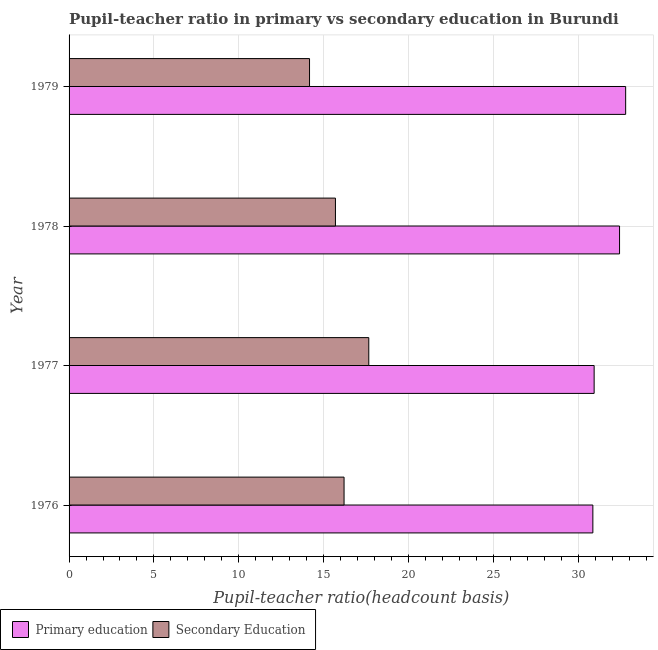How many different coloured bars are there?
Your answer should be very brief. 2. Are the number of bars on each tick of the Y-axis equal?
Your response must be concise. Yes. How many bars are there on the 4th tick from the top?
Provide a short and direct response. 2. How many bars are there on the 3rd tick from the bottom?
Offer a very short reply. 2. In how many cases, is the number of bars for a given year not equal to the number of legend labels?
Provide a succinct answer. 0. What is the pupil teacher ratio on secondary education in 1976?
Provide a succinct answer. 16.2. Across all years, what is the maximum pupil-teacher ratio in primary education?
Your response must be concise. 32.8. Across all years, what is the minimum pupil-teacher ratio in primary education?
Offer a terse response. 30.86. In which year was the pupil-teacher ratio in primary education minimum?
Your answer should be compact. 1976. What is the total pupil teacher ratio on secondary education in the graph?
Your response must be concise. 63.73. What is the difference between the pupil-teacher ratio in primary education in 1977 and that in 1979?
Keep it short and to the point. -1.86. What is the difference between the pupil teacher ratio on secondary education in 1979 and the pupil-teacher ratio in primary education in 1977?
Give a very brief answer. -16.77. What is the average pupil-teacher ratio in primary education per year?
Keep it short and to the point. 31.76. In the year 1978, what is the difference between the pupil teacher ratio on secondary education and pupil-teacher ratio in primary education?
Offer a very short reply. -16.74. What is the ratio of the pupil teacher ratio on secondary education in 1977 to that in 1978?
Offer a very short reply. 1.12. Is the difference between the pupil teacher ratio on secondary education in 1976 and 1979 greater than the difference between the pupil-teacher ratio in primary education in 1976 and 1979?
Give a very brief answer. Yes. What is the difference between the highest and the second highest pupil teacher ratio on secondary education?
Ensure brevity in your answer.  1.46. What is the difference between the highest and the lowest pupil teacher ratio on secondary education?
Your answer should be very brief. 3.49. What does the 2nd bar from the bottom in 1976 represents?
Provide a short and direct response. Secondary Education. How many years are there in the graph?
Your answer should be very brief. 4. What is the difference between two consecutive major ticks on the X-axis?
Your response must be concise. 5. Does the graph contain grids?
Offer a very short reply. Yes. Where does the legend appear in the graph?
Make the answer very short. Bottom left. How many legend labels are there?
Your answer should be compact. 2. How are the legend labels stacked?
Give a very brief answer. Horizontal. What is the title of the graph?
Give a very brief answer. Pupil-teacher ratio in primary vs secondary education in Burundi. Does "Net National savings" appear as one of the legend labels in the graph?
Your answer should be very brief. No. What is the label or title of the X-axis?
Offer a very short reply. Pupil-teacher ratio(headcount basis). What is the Pupil-teacher ratio(headcount basis) in Primary education in 1976?
Keep it short and to the point. 30.86. What is the Pupil-teacher ratio(headcount basis) in Secondary Education in 1976?
Provide a succinct answer. 16.2. What is the Pupil-teacher ratio(headcount basis) of Primary education in 1977?
Ensure brevity in your answer.  30.94. What is the Pupil-teacher ratio(headcount basis) of Secondary Education in 1977?
Provide a short and direct response. 17.66. What is the Pupil-teacher ratio(headcount basis) in Primary education in 1978?
Keep it short and to the point. 32.44. What is the Pupil-teacher ratio(headcount basis) in Secondary Education in 1978?
Keep it short and to the point. 15.7. What is the Pupil-teacher ratio(headcount basis) of Primary education in 1979?
Keep it short and to the point. 32.8. What is the Pupil-teacher ratio(headcount basis) in Secondary Education in 1979?
Your answer should be very brief. 14.17. Across all years, what is the maximum Pupil-teacher ratio(headcount basis) in Primary education?
Ensure brevity in your answer.  32.8. Across all years, what is the maximum Pupil-teacher ratio(headcount basis) in Secondary Education?
Your response must be concise. 17.66. Across all years, what is the minimum Pupil-teacher ratio(headcount basis) of Primary education?
Your answer should be compact. 30.86. Across all years, what is the minimum Pupil-teacher ratio(headcount basis) of Secondary Education?
Give a very brief answer. 14.17. What is the total Pupil-teacher ratio(headcount basis) in Primary education in the graph?
Your answer should be very brief. 127.04. What is the total Pupil-teacher ratio(headcount basis) of Secondary Education in the graph?
Make the answer very short. 63.73. What is the difference between the Pupil-teacher ratio(headcount basis) of Primary education in 1976 and that in 1977?
Offer a terse response. -0.08. What is the difference between the Pupil-teacher ratio(headcount basis) of Secondary Education in 1976 and that in 1977?
Offer a very short reply. -1.46. What is the difference between the Pupil-teacher ratio(headcount basis) in Primary education in 1976 and that in 1978?
Your response must be concise. -1.57. What is the difference between the Pupil-teacher ratio(headcount basis) of Secondary Education in 1976 and that in 1978?
Provide a short and direct response. 0.51. What is the difference between the Pupil-teacher ratio(headcount basis) of Primary education in 1976 and that in 1979?
Keep it short and to the point. -1.93. What is the difference between the Pupil-teacher ratio(headcount basis) in Secondary Education in 1976 and that in 1979?
Give a very brief answer. 2.03. What is the difference between the Pupil-teacher ratio(headcount basis) in Primary education in 1977 and that in 1978?
Give a very brief answer. -1.5. What is the difference between the Pupil-teacher ratio(headcount basis) of Secondary Education in 1977 and that in 1978?
Give a very brief answer. 1.97. What is the difference between the Pupil-teacher ratio(headcount basis) in Primary education in 1977 and that in 1979?
Your answer should be very brief. -1.86. What is the difference between the Pupil-teacher ratio(headcount basis) of Secondary Education in 1977 and that in 1979?
Provide a succinct answer. 3.49. What is the difference between the Pupil-teacher ratio(headcount basis) in Primary education in 1978 and that in 1979?
Make the answer very short. -0.36. What is the difference between the Pupil-teacher ratio(headcount basis) in Secondary Education in 1978 and that in 1979?
Your response must be concise. 1.53. What is the difference between the Pupil-teacher ratio(headcount basis) of Primary education in 1976 and the Pupil-teacher ratio(headcount basis) of Secondary Education in 1977?
Ensure brevity in your answer.  13.2. What is the difference between the Pupil-teacher ratio(headcount basis) in Primary education in 1976 and the Pupil-teacher ratio(headcount basis) in Secondary Education in 1978?
Keep it short and to the point. 15.17. What is the difference between the Pupil-teacher ratio(headcount basis) in Primary education in 1976 and the Pupil-teacher ratio(headcount basis) in Secondary Education in 1979?
Your response must be concise. 16.69. What is the difference between the Pupil-teacher ratio(headcount basis) in Primary education in 1977 and the Pupil-teacher ratio(headcount basis) in Secondary Education in 1978?
Your answer should be very brief. 15.24. What is the difference between the Pupil-teacher ratio(headcount basis) in Primary education in 1977 and the Pupil-teacher ratio(headcount basis) in Secondary Education in 1979?
Provide a short and direct response. 16.77. What is the difference between the Pupil-teacher ratio(headcount basis) in Primary education in 1978 and the Pupil-teacher ratio(headcount basis) in Secondary Education in 1979?
Give a very brief answer. 18.27. What is the average Pupil-teacher ratio(headcount basis) of Primary education per year?
Make the answer very short. 31.76. What is the average Pupil-teacher ratio(headcount basis) of Secondary Education per year?
Make the answer very short. 15.93. In the year 1976, what is the difference between the Pupil-teacher ratio(headcount basis) of Primary education and Pupil-teacher ratio(headcount basis) of Secondary Education?
Keep it short and to the point. 14.66. In the year 1977, what is the difference between the Pupil-teacher ratio(headcount basis) of Primary education and Pupil-teacher ratio(headcount basis) of Secondary Education?
Give a very brief answer. 13.28. In the year 1978, what is the difference between the Pupil-teacher ratio(headcount basis) of Primary education and Pupil-teacher ratio(headcount basis) of Secondary Education?
Offer a very short reply. 16.74. In the year 1979, what is the difference between the Pupil-teacher ratio(headcount basis) in Primary education and Pupil-teacher ratio(headcount basis) in Secondary Education?
Your answer should be very brief. 18.63. What is the ratio of the Pupil-teacher ratio(headcount basis) in Secondary Education in 1976 to that in 1977?
Offer a very short reply. 0.92. What is the ratio of the Pupil-teacher ratio(headcount basis) of Primary education in 1976 to that in 1978?
Your answer should be compact. 0.95. What is the ratio of the Pupil-teacher ratio(headcount basis) in Secondary Education in 1976 to that in 1978?
Provide a short and direct response. 1.03. What is the ratio of the Pupil-teacher ratio(headcount basis) of Primary education in 1976 to that in 1979?
Give a very brief answer. 0.94. What is the ratio of the Pupil-teacher ratio(headcount basis) in Secondary Education in 1976 to that in 1979?
Offer a very short reply. 1.14. What is the ratio of the Pupil-teacher ratio(headcount basis) in Primary education in 1977 to that in 1978?
Your answer should be compact. 0.95. What is the ratio of the Pupil-teacher ratio(headcount basis) of Secondary Education in 1977 to that in 1978?
Keep it short and to the point. 1.13. What is the ratio of the Pupil-teacher ratio(headcount basis) in Primary education in 1977 to that in 1979?
Your response must be concise. 0.94. What is the ratio of the Pupil-teacher ratio(headcount basis) of Secondary Education in 1977 to that in 1979?
Offer a very short reply. 1.25. What is the ratio of the Pupil-teacher ratio(headcount basis) of Secondary Education in 1978 to that in 1979?
Ensure brevity in your answer.  1.11. What is the difference between the highest and the second highest Pupil-teacher ratio(headcount basis) in Primary education?
Offer a terse response. 0.36. What is the difference between the highest and the second highest Pupil-teacher ratio(headcount basis) in Secondary Education?
Your answer should be compact. 1.46. What is the difference between the highest and the lowest Pupil-teacher ratio(headcount basis) in Primary education?
Offer a very short reply. 1.93. What is the difference between the highest and the lowest Pupil-teacher ratio(headcount basis) of Secondary Education?
Ensure brevity in your answer.  3.49. 